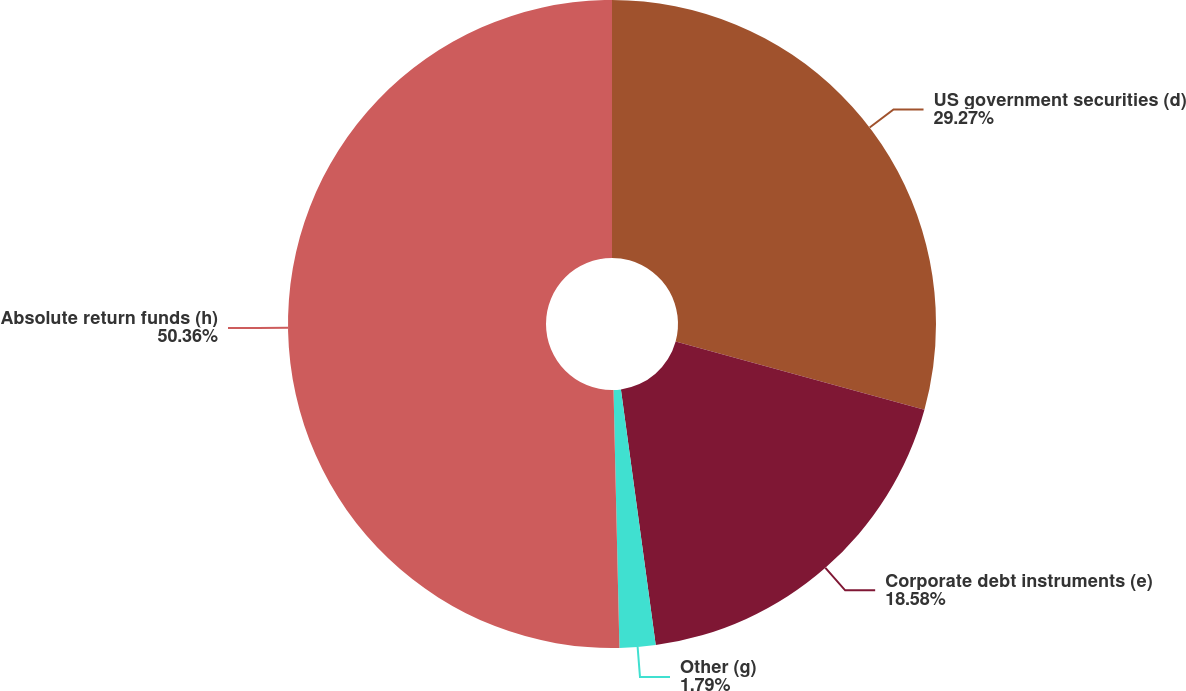Convert chart to OTSL. <chart><loc_0><loc_0><loc_500><loc_500><pie_chart><fcel>US government securities (d)<fcel>Corporate debt instruments (e)<fcel>Other (g)<fcel>Absolute return funds (h)<nl><fcel>29.27%<fcel>18.58%<fcel>1.79%<fcel>50.37%<nl></chart> 